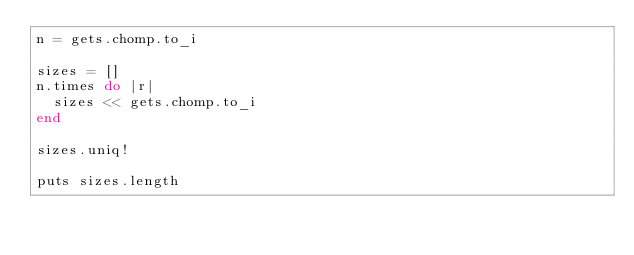<code> <loc_0><loc_0><loc_500><loc_500><_Ruby_>n = gets.chomp.to_i

sizes = []
n.times do |r|
  sizes << gets.chomp.to_i
end

sizes.uniq!

puts sizes.length
</code> 